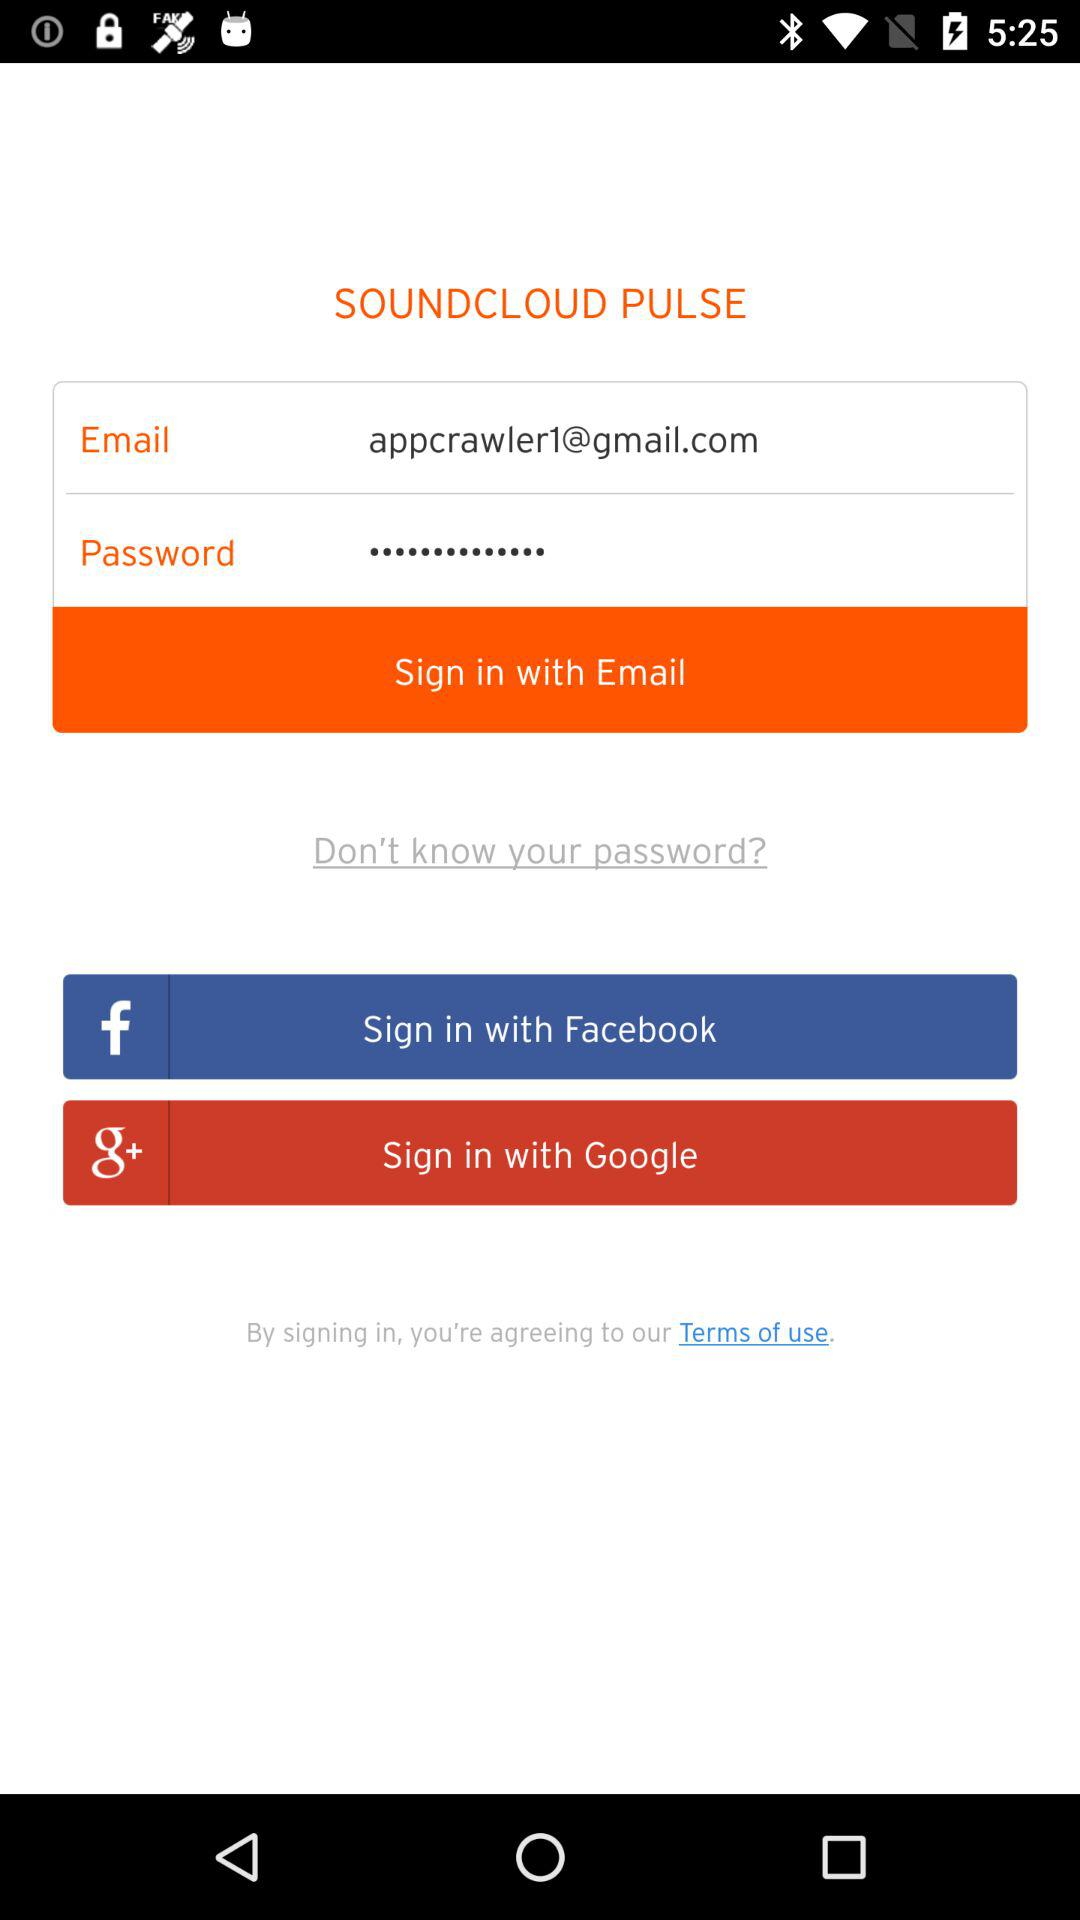What accounts can I use to sign in? You can sign in with "Email", "Facebook" and "Google". 